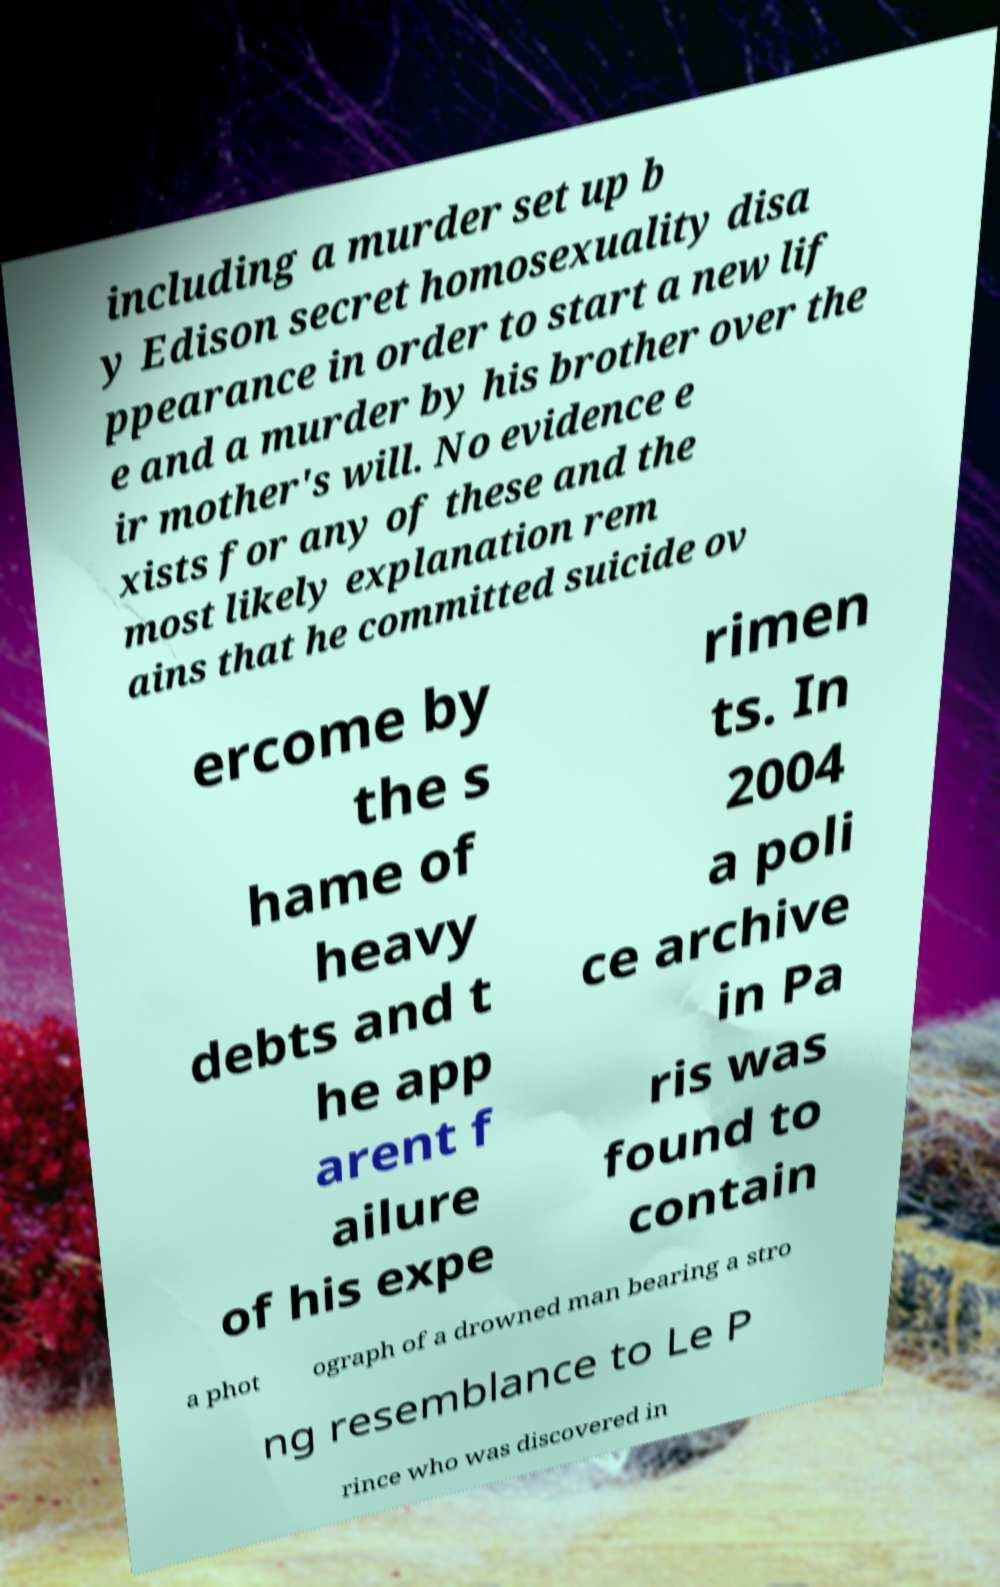Can you accurately transcribe the text from the provided image for me? including a murder set up b y Edison secret homosexuality disa ppearance in order to start a new lif e and a murder by his brother over the ir mother's will. No evidence e xists for any of these and the most likely explanation rem ains that he committed suicide ov ercome by the s hame of heavy debts and t he app arent f ailure of his expe rimen ts. In 2004 a poli ce archive in Pa ris was found to contain a phot ograph of a drowned man bearing a stro ng resemblance to Le P rince who was discovered in 